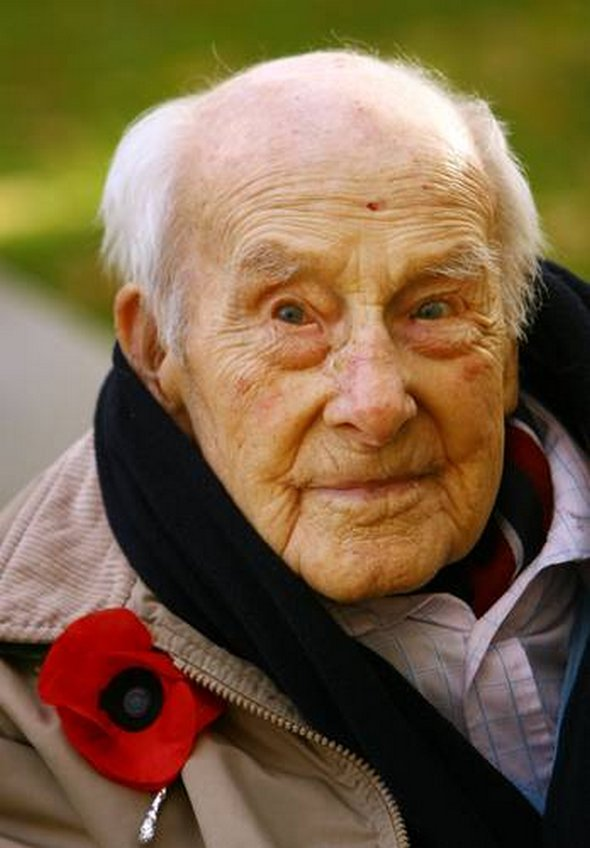What might the man be looking forward to on this day? On this day, the man might be looking forward to joining others in honoring the memories of fallen soldiers. He could be anticipating ceremonies filled with poignant speeches, moments of silence, and the laying of wreaths. Spending time with fellow veterans and sharing stories might also be something he treasures, as it provides a unique sense of camaraderie and mutual understanding. What could be the most poignant moment for him during this day? The most poignant moment for him might be during the two-minute silence observed at 11 a.m. on Remembrance Day, when the entire community comes to a standstill to honor those who lost their lives. This silence offers a powerful and communal pause to reflect deeply on personal and collective histories. For him, it could be a time filled with vivid memories, paying personal tribute to friends and comrades who did not return from the war. The sound of the bugle playing 'The Last Post' might bring a lump to his throat, as it serves as a solemn call to remember and honor the sacrifices made. Imagine if the poppy he wears could speak, what stories would it tell? If the poppy could speak, it would tell stories of countless men and women who stood bravely in the face of unimaginable adversity. It would recount tales of courage in the trenches, the sound of artillery overhead, the camaraderie shared among soldiers, and the bittersweet moments of brief respite. It would speak of letters home, prayers whispered in the dark, and the unwavering hope for peace. The poppy would tell of the somber aftermath—unchecked sacrifices, empty chairs at family dinners, and the persistence of memory in the hearts of those who lived through it. In Henry's case, it might share more personal anecdotes of a young soldier finding unexpected friendship, moments of laughter amidst chaos, and acts of heroism that became second nature. It would whisper of pride, love, and an unbreakable spirit that insists on remembering, year after year. What about later in the evening? What might he do to continue honoring the memory of his comrades? Later in the evening, Henry might engage in a quieter, more personal form of remembrance. Perhaps he visits a local pub where he and some surviving friends gather in a less formal setting, reminiscing about the past and toasting to absent friends. Alternatively, he might light a candle at home, sit beside it with old photographs and letters, allowing himself the solitary space to grieve and remember. He could listen to wartime songs or read passages from his diary written during the war, sustaining a connection with those he lost and ensuring their memories live on through his reflections. 